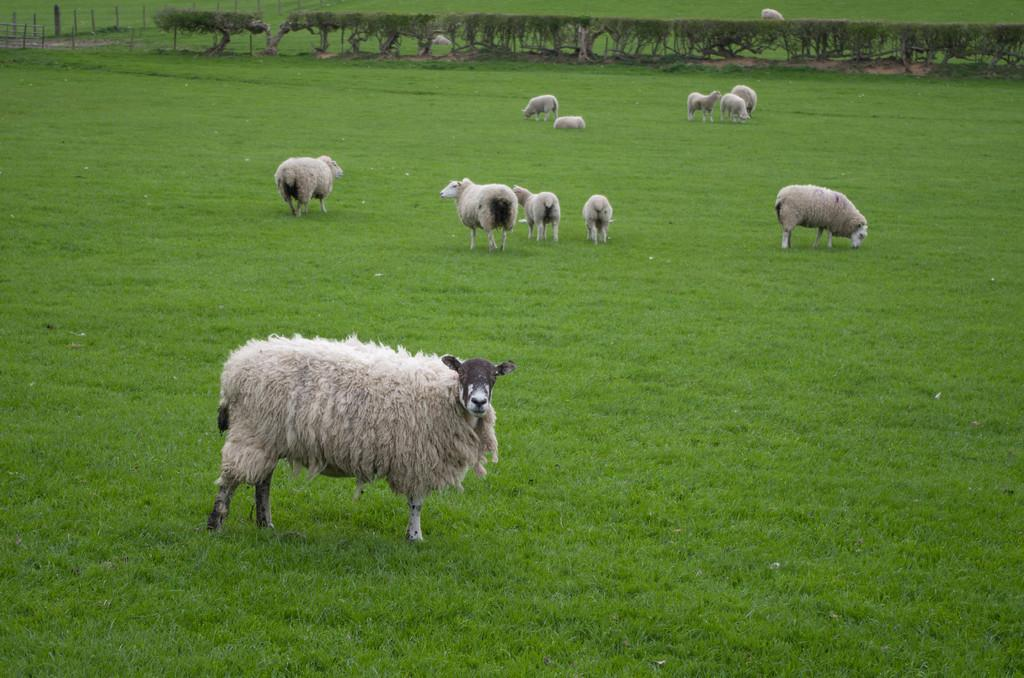What is the main setting of the image? There is an open grass ground in the image. What animals can be seen on the grass ground? There are white-colored sheep on the grass ground. What can be seen in the background of the image? There are trees and poles in the background of the image. What type of cloth is draped over the sheep in the image? There is no cloth draped over the sheep in the image; they are simply white-colored sheep grazing on the grass ground. 